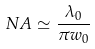<formula> <loc_0><loc_0><loc_500><loc_500>N A \simeq \frac { \lambda _ { 0 } } { \pi w _ { 0 } }</formula> 